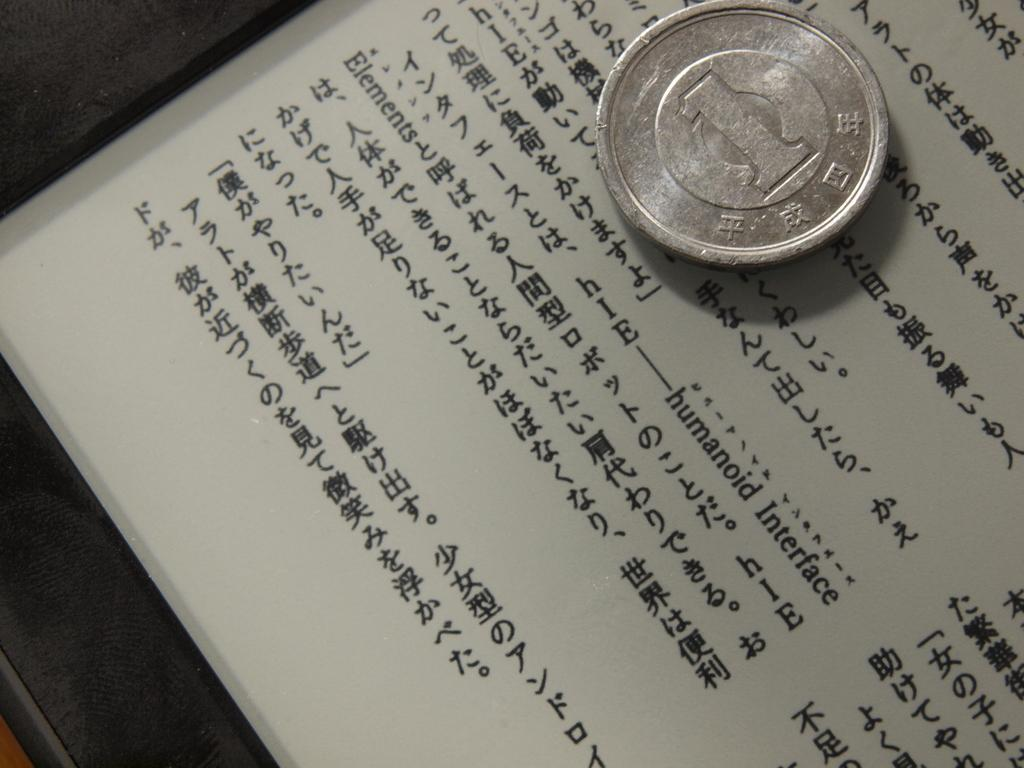<image>
Provide a brief description of the given image. A silver coin with a numeral one on it sitting on top of a paper with asian writing. 